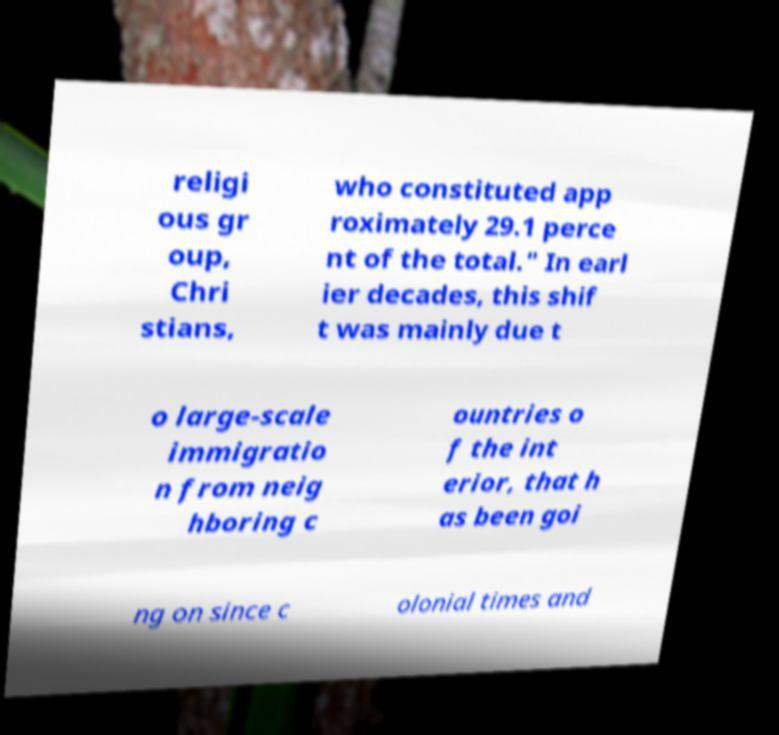There's text embedded in this image that I need extracted. Can you transcribe it verbatim? religi ous gr oup, Chri stians, who constituted app roximately 29.1 perce nt of the total." In earl ier decades, this shif t was mainly due t o large-scale immigratio n from neig hboring c ountries o f the int erior, that h as been goi ng on since c olonial times and 